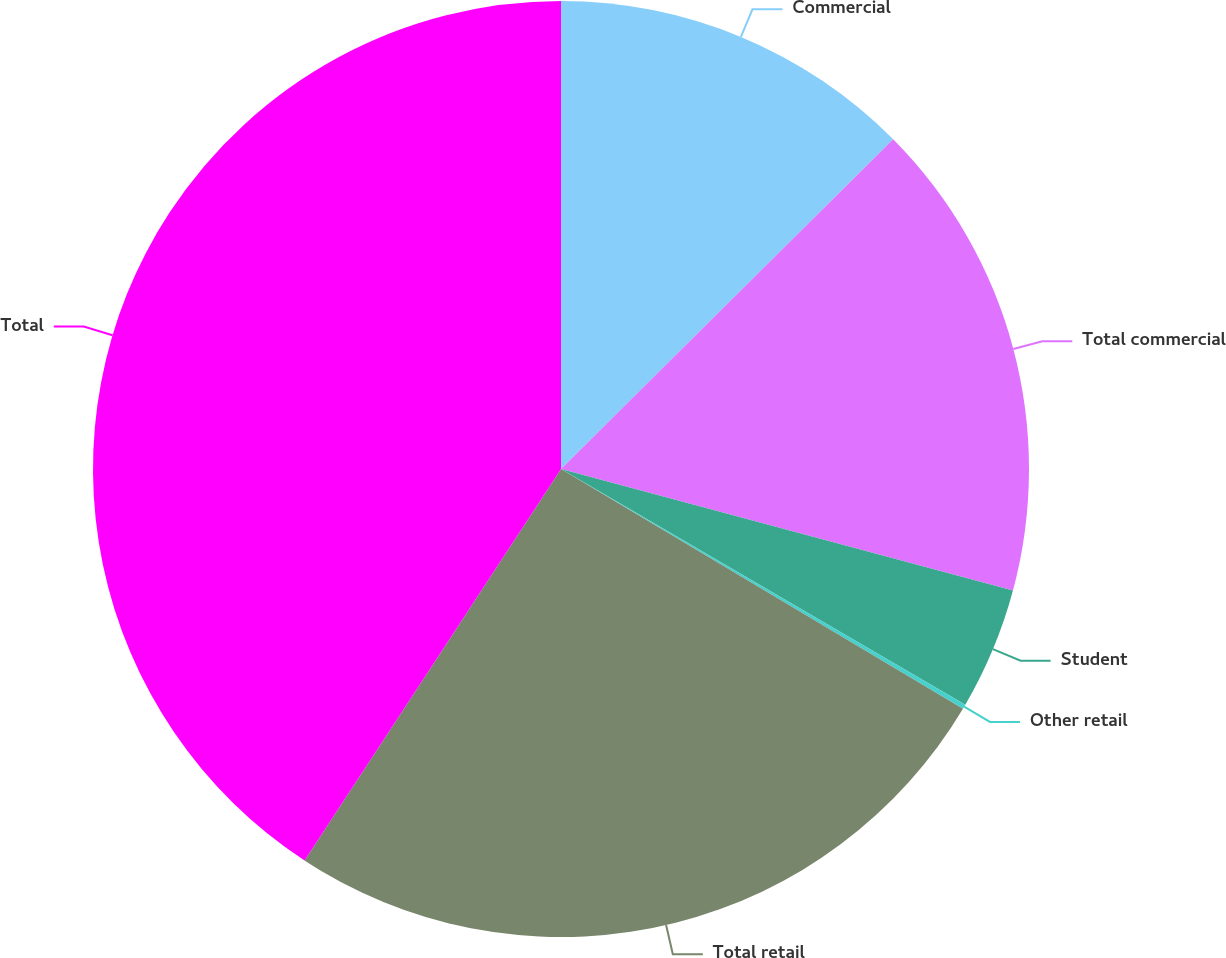<chart> <loc_0><loc_0><loc_500><loc_500><pie_chart><fcel>Commercial<fcel>Total commercial<fcel>Student<fcel>Other retail<fcel>Total retail<fcel>Total<nl><fcel>12.56%<fcel>16.62%<fcel>4.22%<fcel>0.16%<fcel>25.67%<fcel>40.77%<nl></chart> 